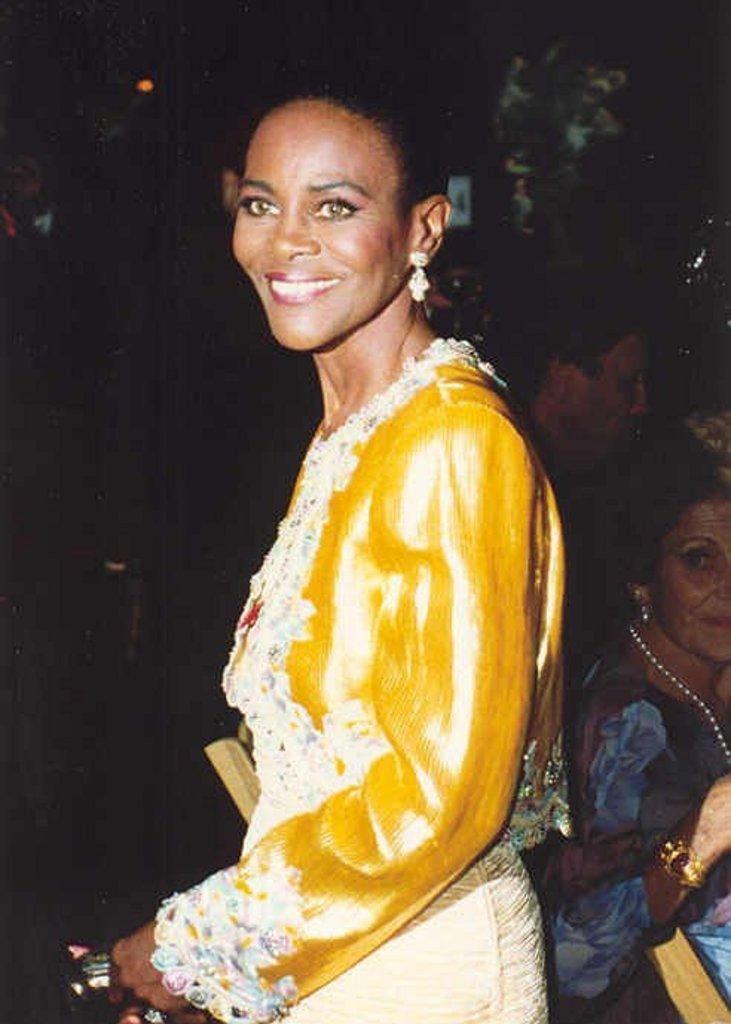Who is the main subject in the image? There is a woman in the image. What is the woman doing in the image? The woman is standing. What is the woman wearing in the image? The woman is wearing a yellow top. What is the woman's facial expression in the image? The woman is smiling. What can be seen in the background of the image? There are people sitting on chairs in the background of the image. Is the woman playing basketball in the image? No, there is no basketball or any indication of a basketball game in the image. 